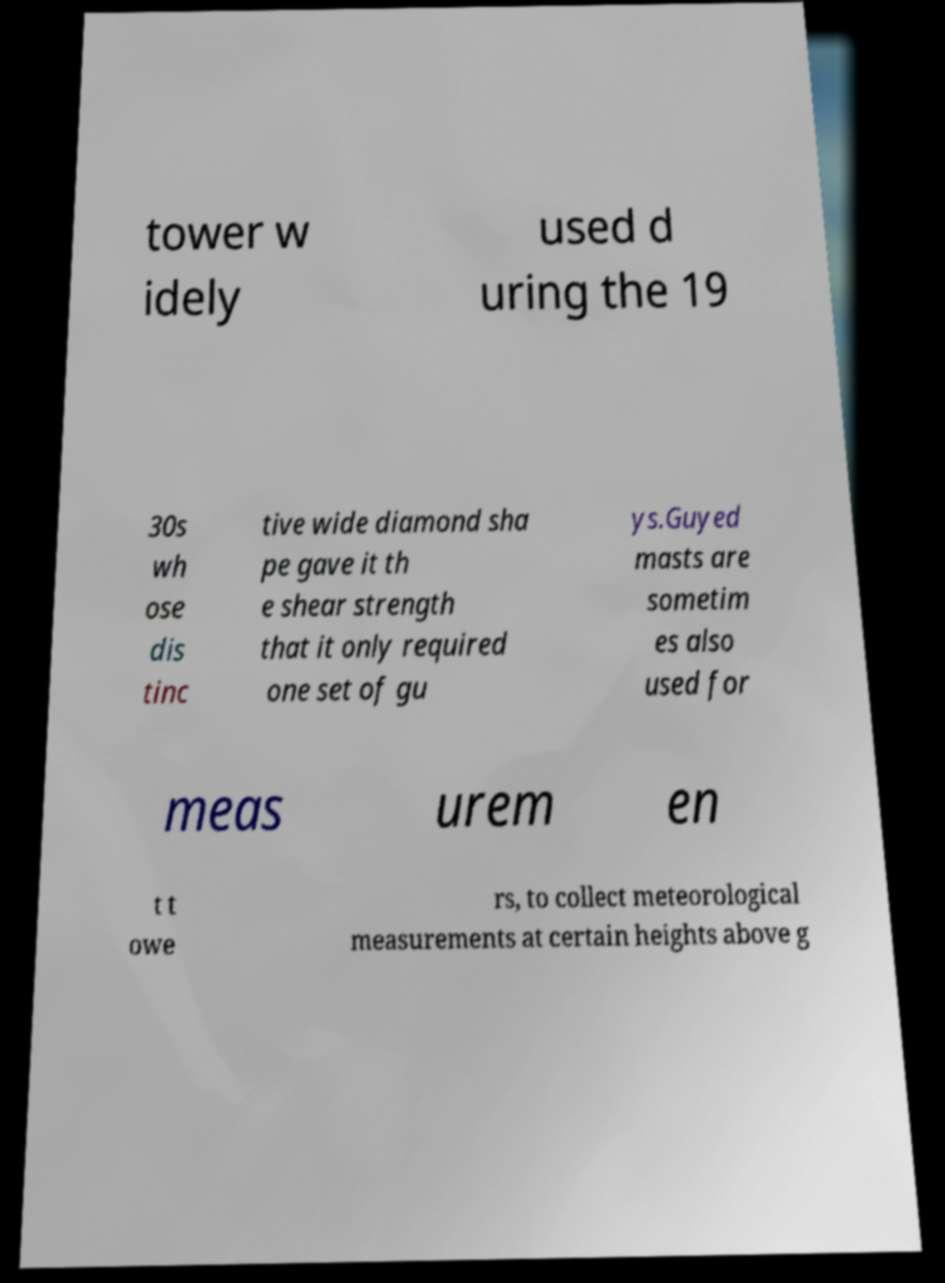For documentation purposes, I need the text within this image transcribed. Could you provide that? tower w idely used d uring the 19 30s wh ose dis tinc tive wide diamond sha pe gave it th e shear strength that it only required one set of gu ys.Guyed masts are sometim es also used for meas urem en t t owe rs, to collect meteorological measurements at certain heights above g 